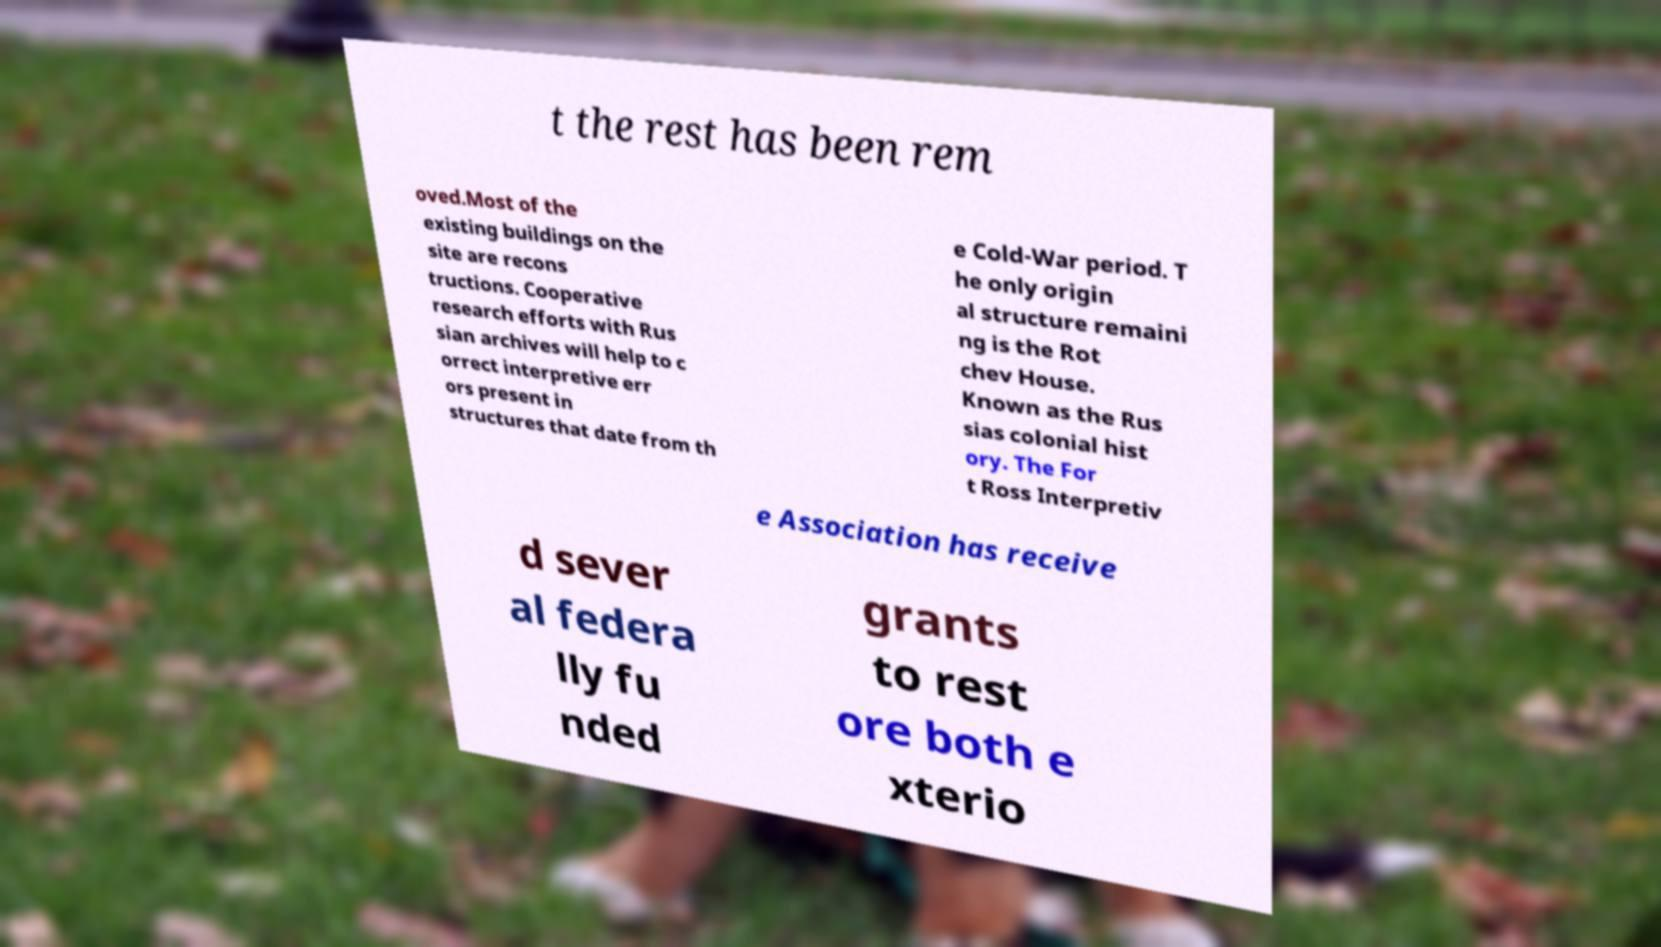What messages or text are displayed in this image? I need them in a readable, typed format. t the rest has been rem oved.Most of the existing buildings on the site are recons tructions. Cooperative research efforts with Rus sian archives will help to c orrect interpretive err ors present in structures that date from th e Cold-War period. T he only origin al structure remaini ng is the Rot chev House. Known as the Rus sias colonial hist ory. The For t Ross Interpretiv e Association has receive d sever al federa lly fu nded grants to rest ore both e xterio 